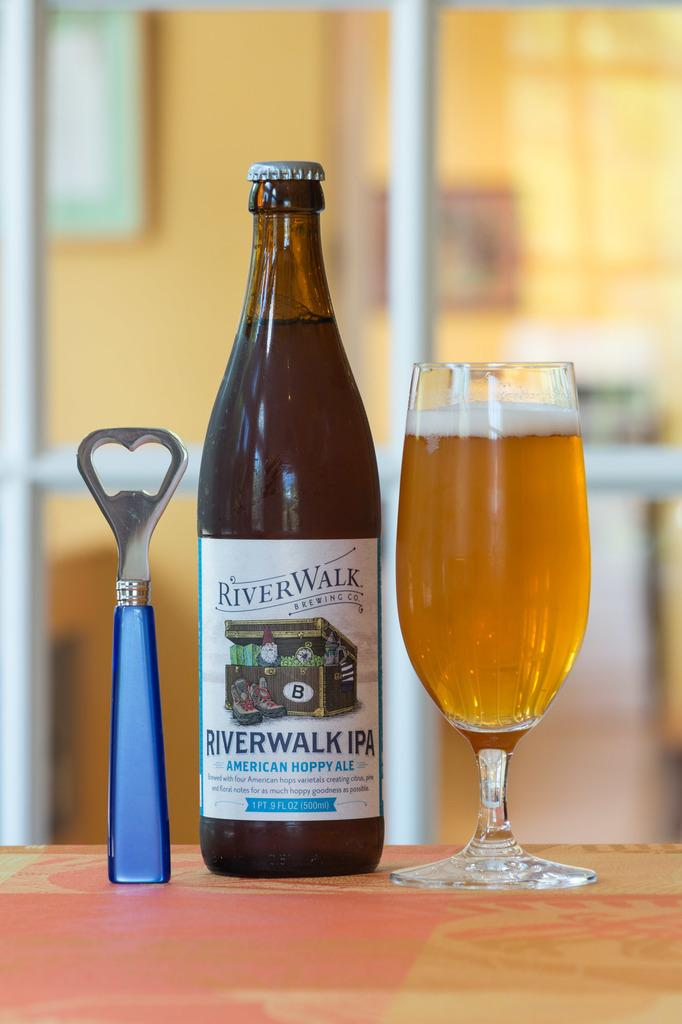<image>
Describe the image concisely. a glass and bottle of River Walk IPA with a bottle opener 